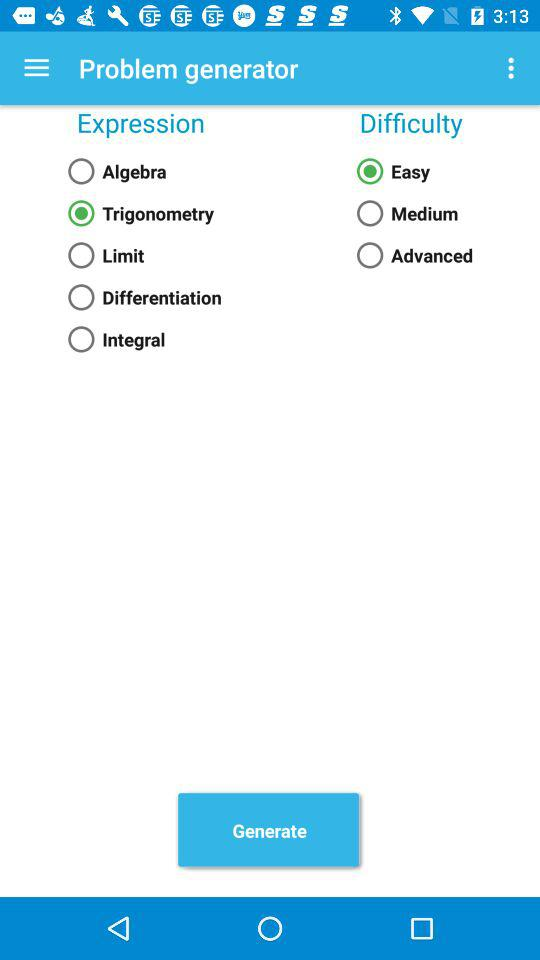What is the selected expression? The selected expression is "Trigonometry". 